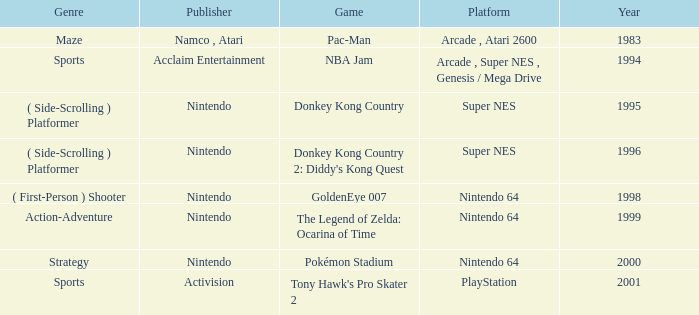Which Genre has a Game of tony hawk's pro skater 2? Sports. 